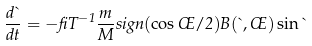<formula> <loc_0><loc_0><loc_500><loc_500>\frac { d \theta } { d t } = - \beta T ^ { - 1 } \frac { m } { M } s i g n ( \cos \phi / 2 ) B ( \theta , \phi ) \sin \theta</formula> 